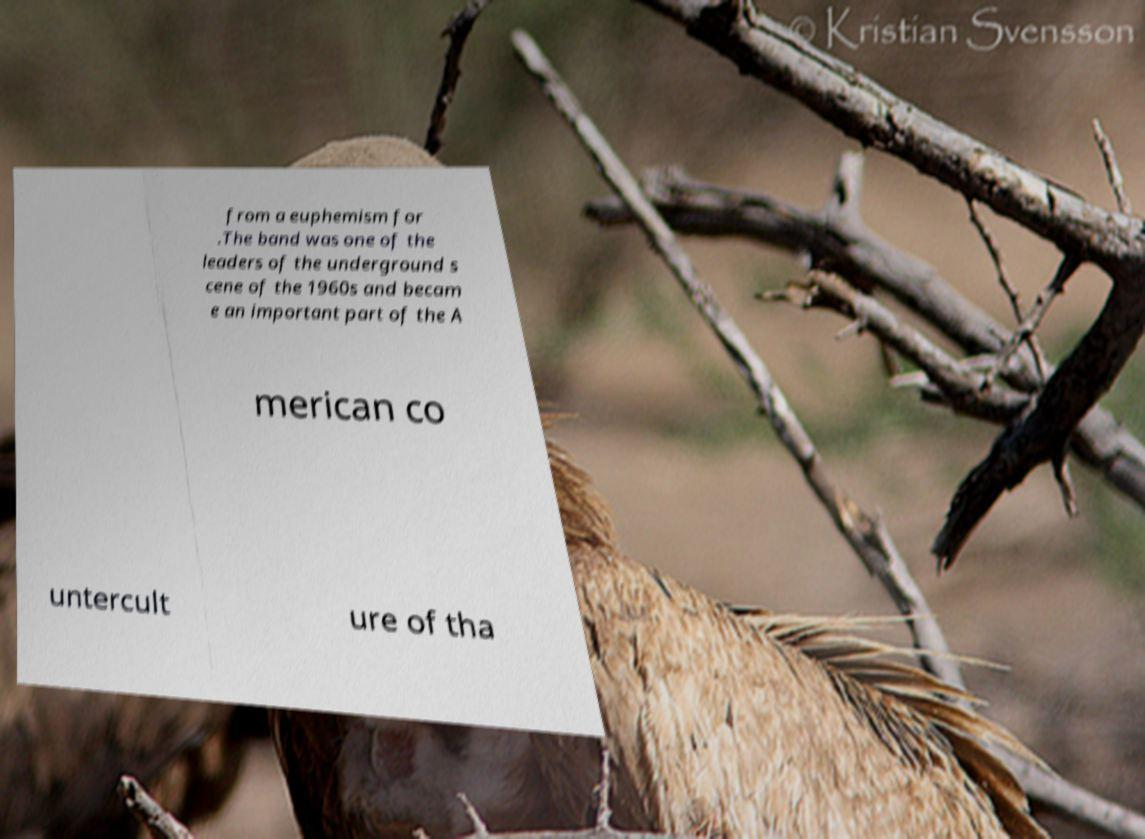For documentation purposes, I need the text within this image transcribed. Could you provide that? from a euphemism for .The band was one of the leaders of the underground s cene of the 1960s and becam e an important part of the A merican co untercult ure of tha 